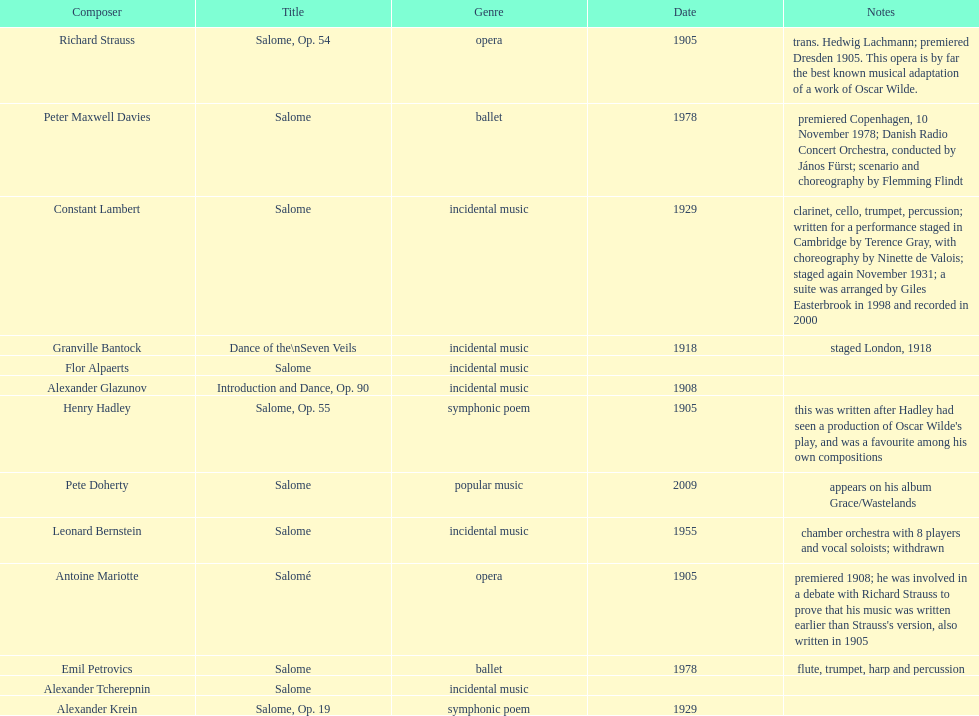What is the difference in years of granville bantock's work compared to pete dohert? 91. 